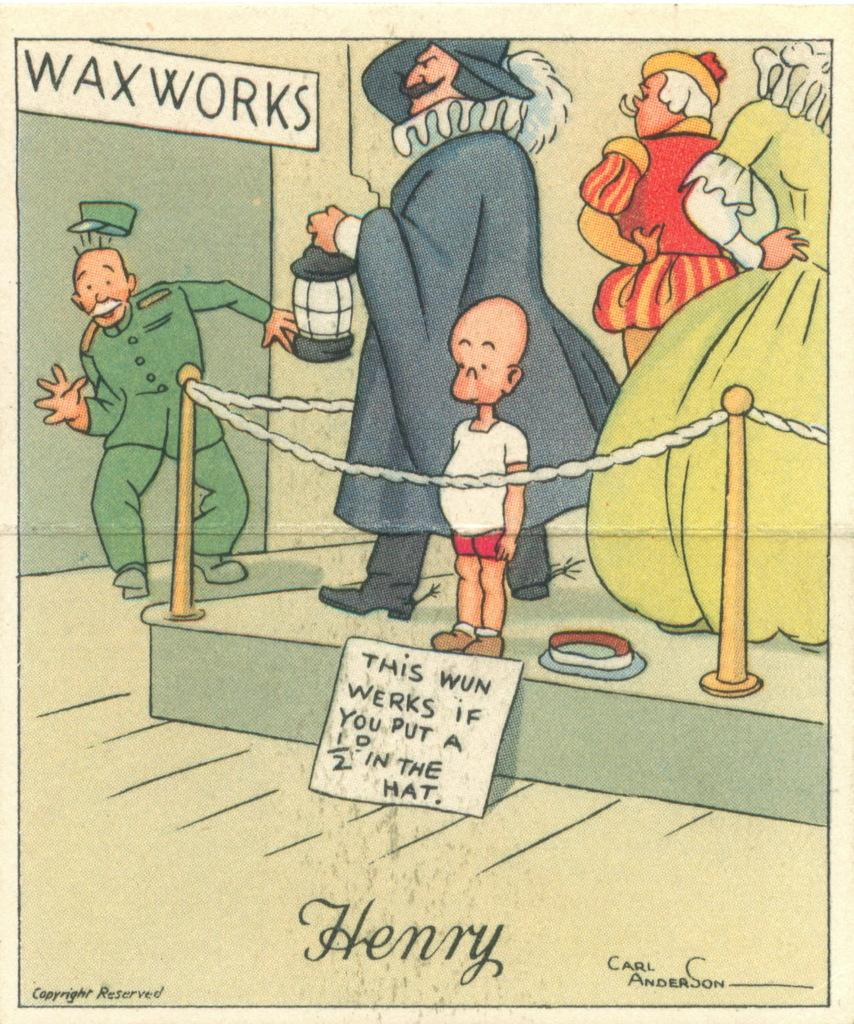What is present on the poster in the image? There is a poster in the image that contains cartoon images. What type of images can be seen on the poster? The images on the poster are cartoon images. Is there any text on the poster? Yes, there is text on the poster. How many clocks are depicted in the cartoon images on the poster? There is no information about clocks in the image, as the poster contains cartoon images but no specific details about their content. 